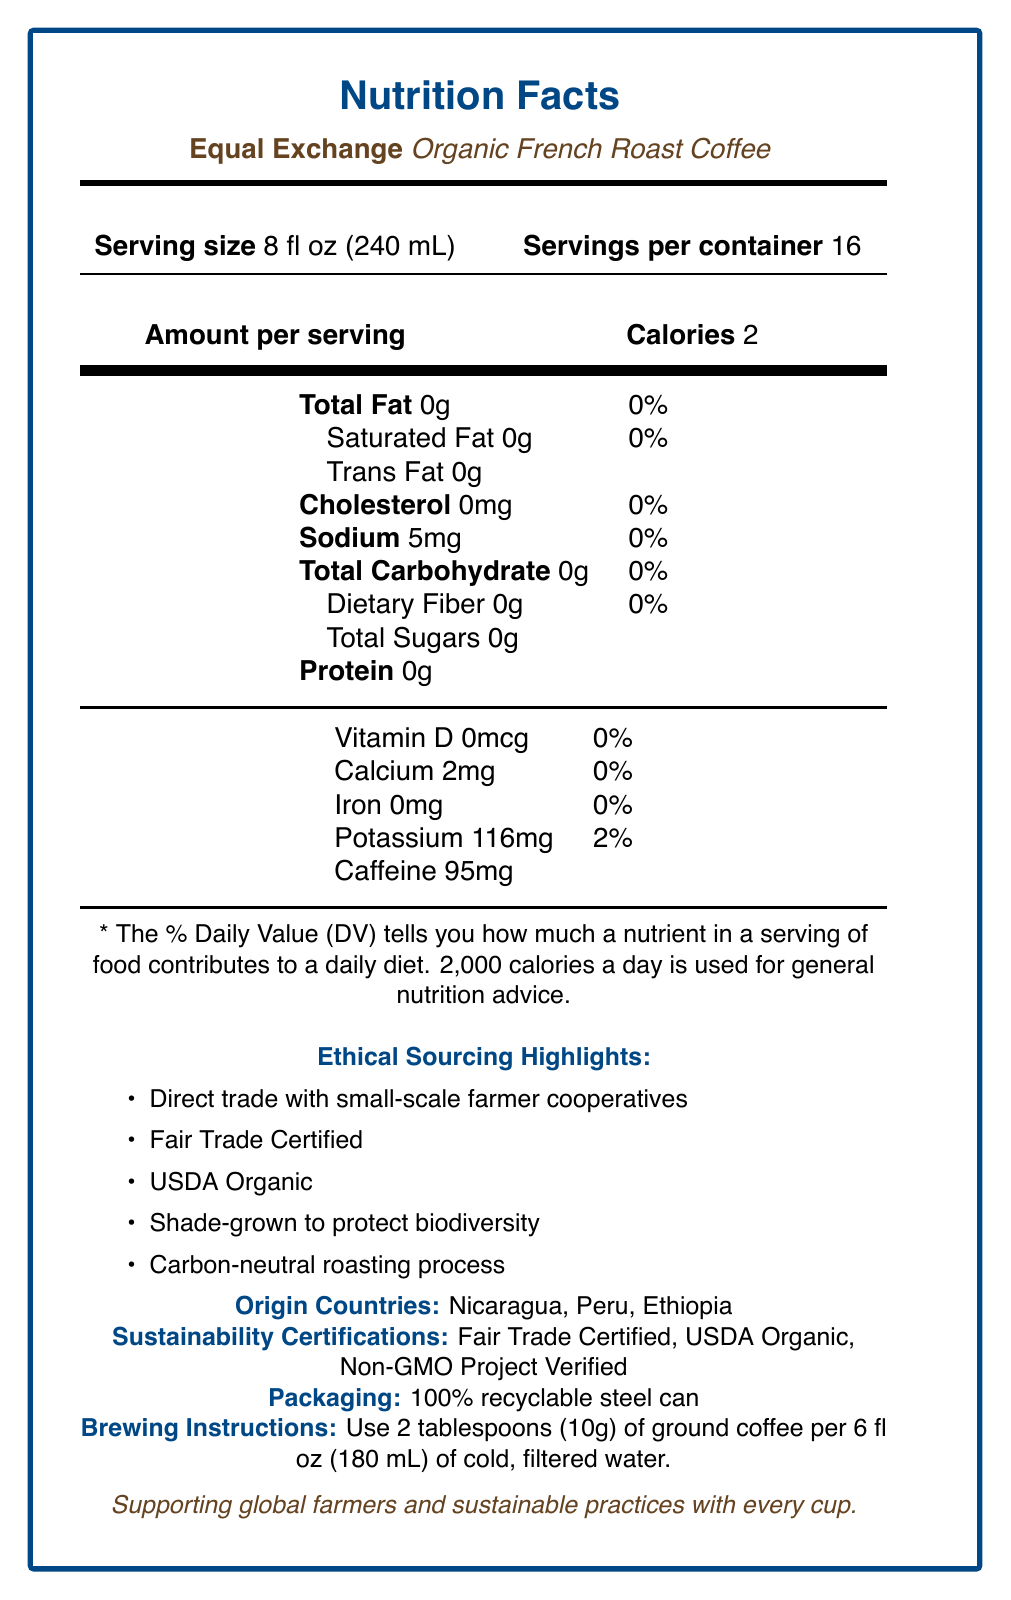What is the serving size of the Organic French Roast Coffee? The serving size is specified in the document as 8 fl oz (240 mL).
Answer: 8 fl oz (240 mL) How many servings are there in a container? The document states that there are 16 servings per container.
Answer: 16 How many calories are in one serving of the Organic French Roast Coffee? The document indicates that there are 2 calories per serving.
Answer: 2 Which countries are the origin sources for the coffee in this product? The origin countries listed in the document are Nicaragua, Peru, and Ethiopia.
Answer: Nicaragua, Peru, Ethiopia What is the serving size recommended for brewing? This information is found under the brewing instructions section.
Answer: 2 tablespoons (10g) of ground coffee per 6 fl oz (180 mL) of cold, filtered water What are some of the ethical sourcing highlights of the Organic French Roast Coffee? The document lists these highlights under the "Ethical Sourcing Highlights" section.
Answer: Direct trade with small-scale farmer cooperatives, Fair Trade Certified, USDA Organic, Shade-grown to protect biodiversity, Carbon-neutral roasting process How much caffeine is in a serving of this coffee? The document specifies that one serving contains 95mg of caffeine.
Answer: 95mg What is the company's mission? The company's mission is detailed in the document under "company mission".
Answer: To build long-term trade partnerships that are economically just and environmentally sound, fostering mutually beneficial relationships between farmers and consumers. How much potassium is in each serving? The document shows that each serving has 116mg of potassium.
Answer: 116mg Is the packaging for this coffee recyclable? The document states that the packaging is a 100% recyclable steel can.
Answer: Yes Which of the following is not a sustainability certification mentioned for the Organic French Roast Coffee? A. Fair Trade Certified B. USDA Organic C. Rainforest Alliance D. Non-GMO Project Verified The document mentions Fair Trade Certified, USDA Organic, and Non-GMO Project Verified. Rainforest Alliance is not mentioned.
Answer: C. Rainforest Alliance What percentage of Equal Exchange's revenue goes directly to small-scale farmers? The document mentions that over 40% of the revenue goes directly to small-scale farmers.
Answer: Over 40% How does the Organic French Roast Coffee contribute to biodiversity according to its ethical sourcing highlights? A. It is grown with synthetic pesticides. B. It is shade-grown. C. It uses genetically modified organisms. According to the document, the coffee is shade-grown to protect biodiversity.
Answer: B. It is shade-grown. Are there any sugars in the Organic French Roast Coffee? The document states that the total sugars are 0g.
Answer: No Describe the main idea of the document. The document focuses on providing detailed nutritional facts and ethical sourcing practices, emphasizing the product's commitment to sustainability, farmer impact, and environmental soundness.
Answer: The document provides nutritional information for Equal Exchange's Organic French Roast Coffee, including its serving size, calorie count, and nutrient content. It also highlights the ethical sourcing practices, origin countries, sustainability certifications, recyclable packaging, and company mission focused on supporting small-scale farmer cooperatives and promoting sustainable practices. What specific community initiatives are supported by Equal Exchange's revenue contribution to farmers? The document mentions that over 40% of Equal Exchange's revenue supports community development projects and sustainable agriculture practices but does not specify the exact initiatives.
Answer: Not enough information 